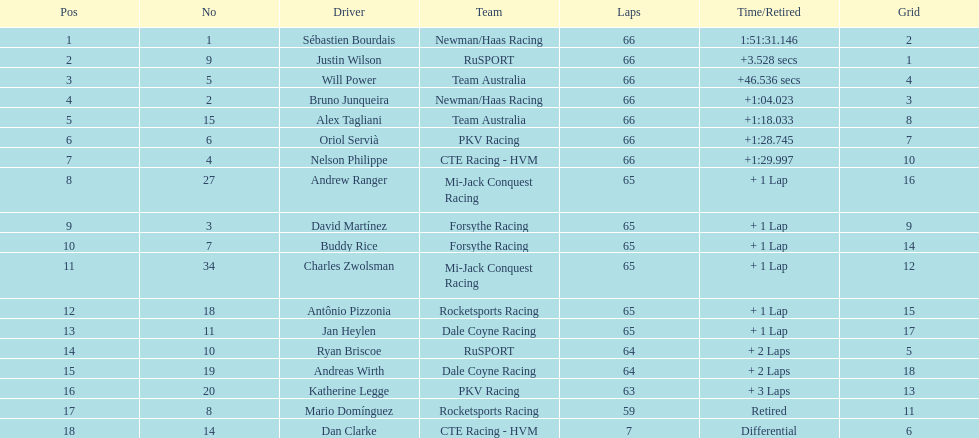At the 2006 gran premio telmex, who scored the highest number of points? Sébastien Bourdais. 